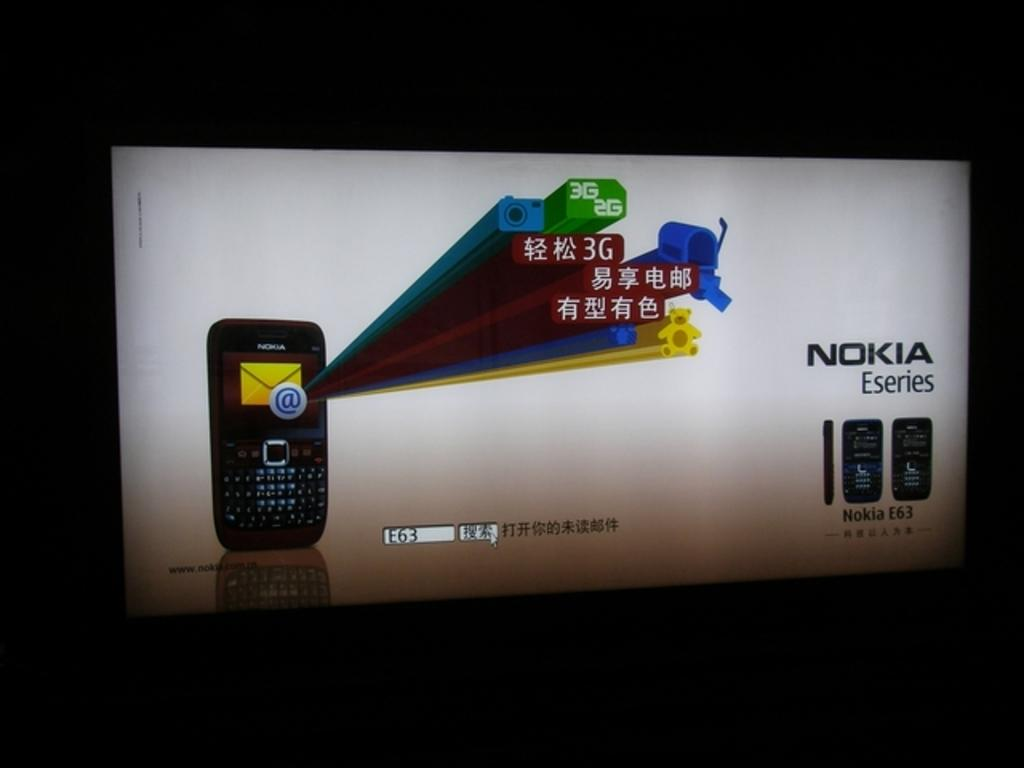<image>
Summarize the visual content of the image. A monitor screen depicting a Nokia series phone image. 